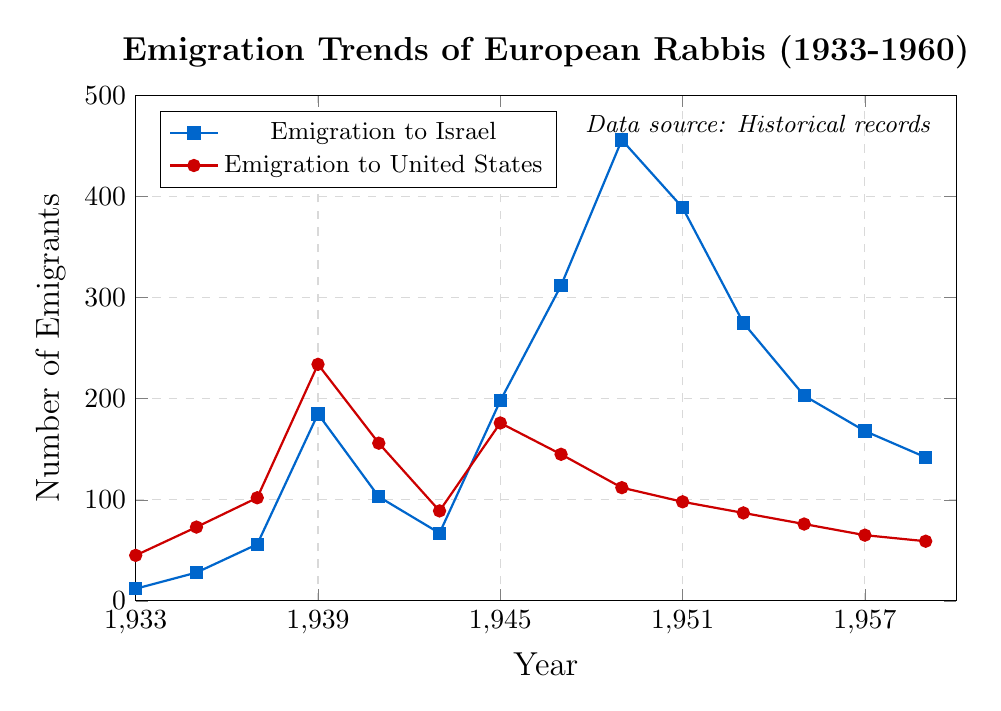When did emigration to Israel first significantly surpass emigration to the United States? Examine the points where the lines cross. The first significant surpassing happens around 1945 where emigrations to Israel spike to 198, while those to the United States increase to 176.
Answer: 1945 During which year was the emigration to Israel at its peak? Look for the highest point of the line representing Israel, which is 456. This peak occurs in 1949.
Answer: 1949 How many more rabbis emigrated to Israel than to the United States in 1949? Subtract the emigration to the US in 1949 (112) from the emigration to Israel in the same year (456). 456 - 112 = 344.
Answer: 344 Which year shows the smallest difference in the number of rabbis emigrating to Israel compared to the United States? Calculate the differences for each year and identify the smallest one. In 1945, the difference is smallest, 198 - 176 = 22.
Answer: 1945 What was the trend in emigration to Israel from 1933 to 1939? Observe the emigration to Israel line from 1933 to 1939. The trend shows a steady increase from 12 in 1933 to 185 in 1939.
Answer: Increasing trend What are the total emigrations to the United States from 1939 to 1945? Sum the data points for the years 1939 (234), 1941 (156), 1943 (89), and 1945 (176). 234 + 156 + 89 + 176 = 655.
Answer: 655 Which year had the lowest emigration to the United States after 1945? Identify the lowest point on the US emigration line after 1945. In 1959, the number is 59, which is the lowest.
Answer: 1959 How do the emigration trends change after World War II (after 1945) for Israel and the United States? Examine the trend lines post-1945. For Israel, the numbers initially increase dramatically up to 1949 and then generally decrease. For the US, the numbers generally decrease gradually from 1945 onwards.
Answer: Increase then decrease for Israel, decrease for the US What was the emigration to the United States in 1933 compared to 1943? Compare the number of emigrants in 1933 (45) to that in 1943 (89). 89 - 45 = 44, so it's an increase of 44.
Answer: 44 more in 1943 How many rabbis emigrated to Israel during the period of 1947 to 1953? Sum the data points for the years 1947 (312), 1949 (456), 1951 (389), and 1953 (275). 312 + 456 + 389 + 275 = 1432.
Answer: 1432 